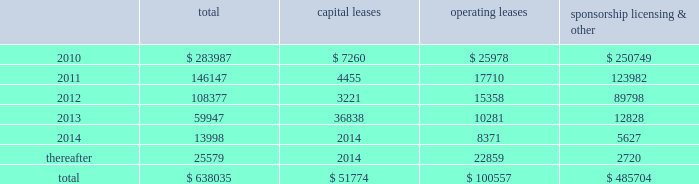Mastercard incorporated notes to consolidated financial statements 2014 ( continued ) ( in thousands , except percent and per share data ) equity awards was $ 30333 , $ 20726 and $ 19828 for the years ended december 31 , 2009 , 2008 and 2007 , respectively .
The income tax benefit related to options exercised during 2009 was $ 7545 .
The additional paid-in capital balance attributed to the equity awards was $ 197350 , $ 135538 and $ 114637 as of december 31 , 2009 , 2008 and 2007 , respectively .
On july 18 , 2006 , the company 2019s stockholders approved the mastercard incorporated 2006 non-employee director equity compensation plan ( the 201cdirector plan 201d ) .
The director plan provides for awards of deferred stock units ( 201cdsus 201d ) to each director of the company who is not a current employee of the company .
There are 100 shares of class a common stock reserved for dsu awards under the director plan .
During the years ended december 31 , 2009 , 2008 and 2007 , the company granted 7 dsus , 4 dsus and 8 dsus , respectively .
The fair value of the dsus was based on the closing stock price on the new york stock exchange of the company 2019s class a common stock on the date of grant .
The weighted average grant-date fair value of dsus granted during the years ended december 31 , 2009 , 2008 and 2007 was $ 168.18 , $ 284.92 and $ 139.27 , respectively .
The dsus vested immediately upon grant and will be settled in shares of the company 2019s class a common stock on the fourth anniversary of the date of grant .
Accordingly , the company recorded general and administrative expense of $ 1151 , $ 1209 and $ 1051 for the dsus for the years ended december 31 , 2009 , 2008 and 2007 , respectively .
The total income tax benefit recognized in the income statement for dsus was $ 410 , $ 371 and $ 413 for the years ended december 31 , 2009 , 2008 and 2007 , respectively .
Note 18 .
Commitments at december 31 , 2009 , the company had the following future minimum payments due under non-cancelable agreements : capital leases operating leases sponsorship , licensing & .
Included in the table above are capital leases with imputed interest expense of $ 7929 and a net present value of minimum lease payments of $ 43845 .
In addition , at december 31 , 2009 , $ 63616 of the future minimum payments in the table above for leases , sponsorship , licensing and other agreements was accrued .
Consolidated rental expense for the company 2019s office space , which is recognized on a straight line basis over the life of the lease , was approximately $ 39586 , $ 42905 and $ 35614 for the years ended december 31 , 2009 , 2008 and 2007 , respectively .
Consolidated lease expense for automobiles , computer equipment and office equipment was $ 9137 , $ 7694 and $ 7679 for the years ended december 31 , 2009 , 2008 and 2007 , respectively .
In january 2003 , mastercard purchased a building in kansas city , missouri for approximately $ 23572 .
The building is a co-processing data center which replaced a back-up data center in lake success , new york .
During 2003 , mastercard entered into agreements with the city of kansas city for ( i ) the sale-leaseback of the building and related equipment which totaled $ 36382 and ( ii ) the purchase of municipal bonds for the same amount .
What is the percentage of operating leases among the total future minimum payments , in 2010? 
Rationale: it is the value related to operating leases divided by the total value of future minimum payments in 2010 , then turned into a percentage .
Computations: (25978 / 283987)
Answer: 0.09148. 